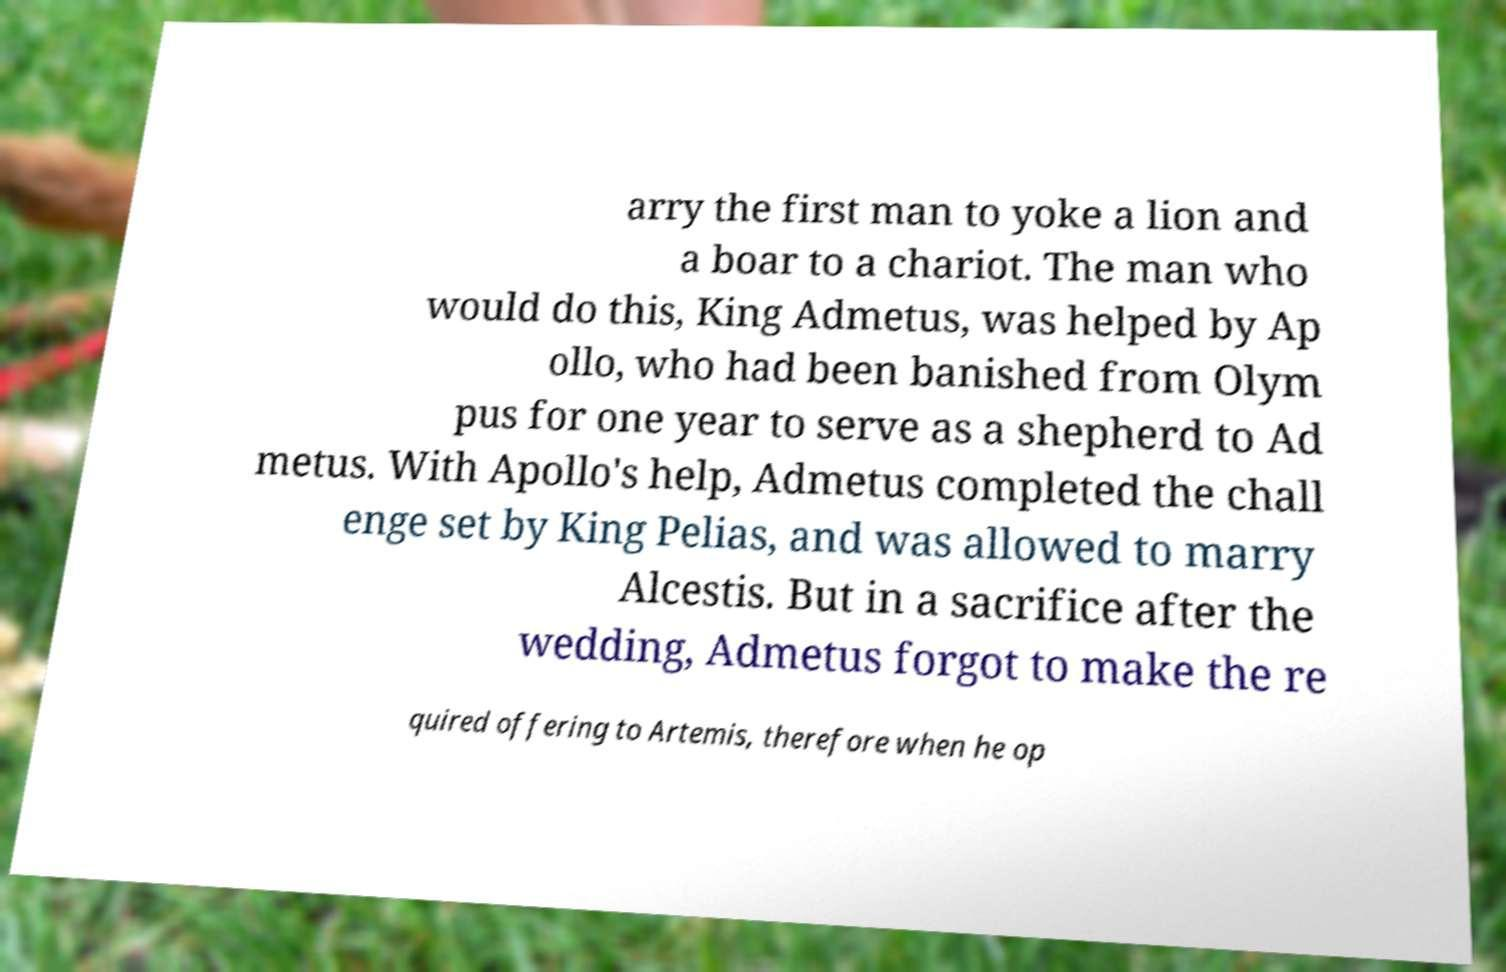Can you read and provide the text displayed in the image?This photo seems to have some interesting text. Can you extract and type it out for me? arry the first man to yoke a lion and a boar to a chariot. The man who would do this, King Admetus, was helped by Ap ollo, who had been banished from Olym pus for one year to serve as a shepherd to Ad metus. With Apollo's help, Admetus completed the chall enge set by King Pelias, and was allowed to marry Alcestis. But in a sacrifice after the wedding, Admetus forgot to make the re quired offering to Artemis, therefore when he op 